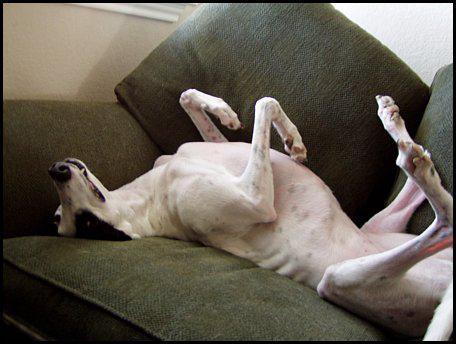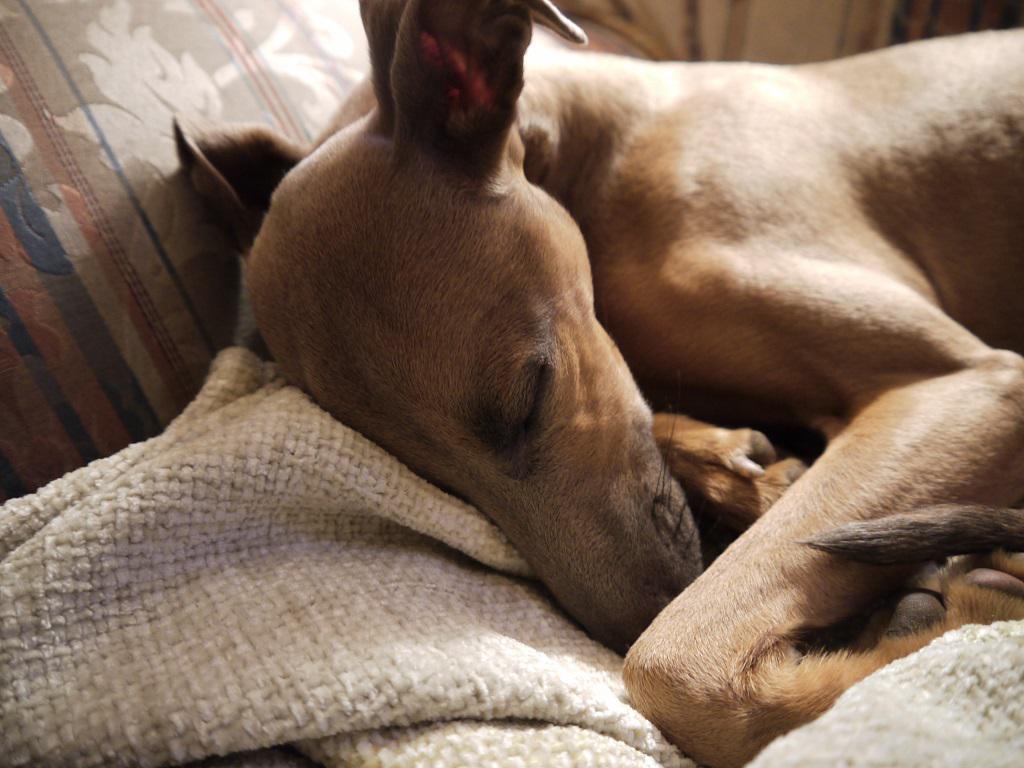The first image is the image on the left, the second image is the image on the right. Considering the images on both sides, is "There are two dogs and zero humans, and the dog on the right is laying on a blanket." valid? Answer yes or no. Yes. The first image is the image on the left, the second image is the image on the right. For the images displayed, is the sentence "An image contains one leftward-facing snoozing brown dog, snuggled with folds of blanket and no human present." factually correct? Answer yes or no. Yes. 